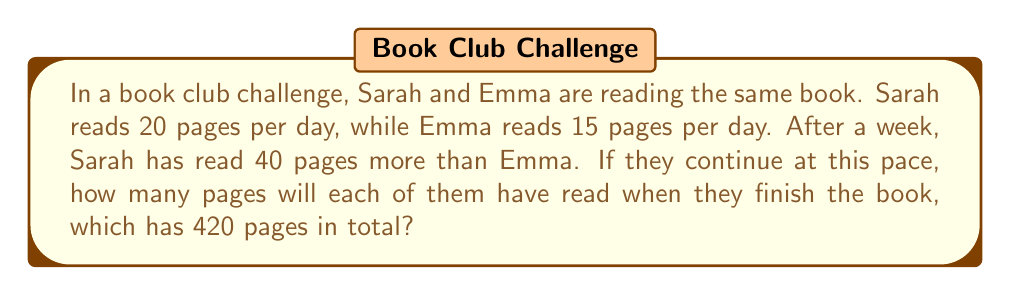Solve this math problem. Let's approach this step-by-step:

1) First, let's define our variables:
   Let $x$ be the number of days it takes to finish the book.

2) Now, we can set up two equations:
   Sarah's pages: $20x = 420$
   Emma's pages: $15x + 40 = 420$

3) Let's solve the first equation:
   $20x = 420$
   $x = 21$ days

4) Now we know it takes 21 days to finish the book.

5) We can calculate how many pages Sarah reads:
   Sarah's pages = $20 \times 21 = 420$ pages

6) For Emma, we can either:
   a) Use the second equation: $15 \times 21 + 40 = 355$ pages
   b) Or subtract 40 from Sarah's total: $420 - 40 = 380$ pages

Therefore, Sarah will read 420 pages and Emma will read 380 pages.
Answer: Sarah: 420 pages, Emma: 380 pages 